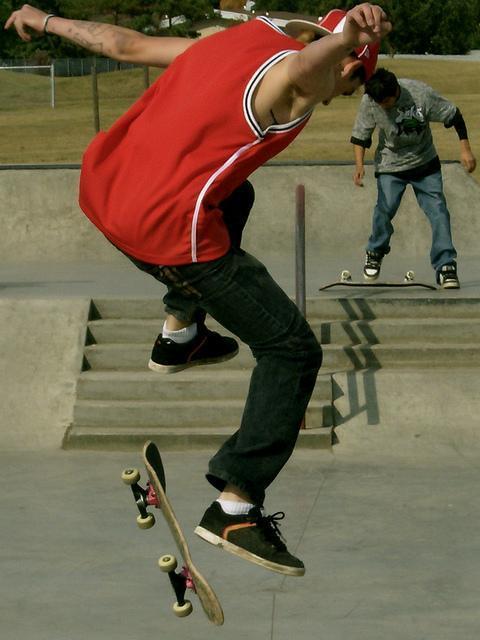How many skateboards in the photo?
Give a very brief answer. 2. How many wheels are on this skateboard?
Give a very brief answer. 4. How many people can be seen?
Give a very brief answer. 2. How many teddy bears are wearing white?
Give a very brief answer. 0. 